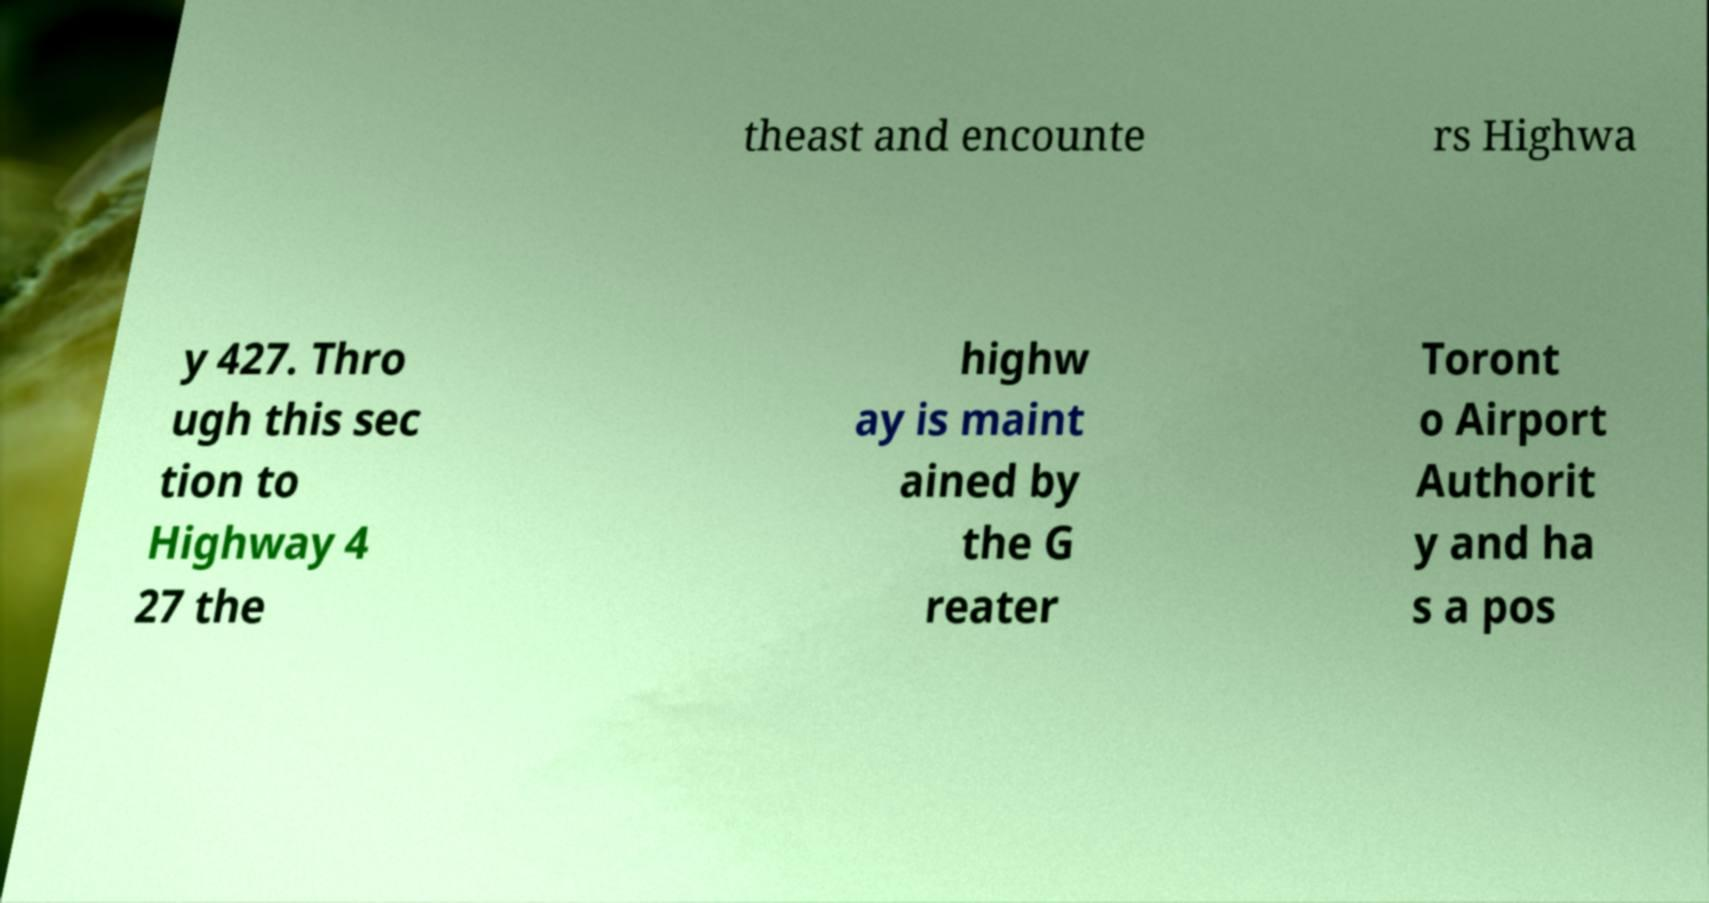Please read and relay the text visible in this image. What does it say? theast and encounte rs Highwa y 427. Thro ugh this sec tion to Highway 4 27 the highw ay is maint ained by the G reater Toront o Airport Authorit y and ha s a pos 